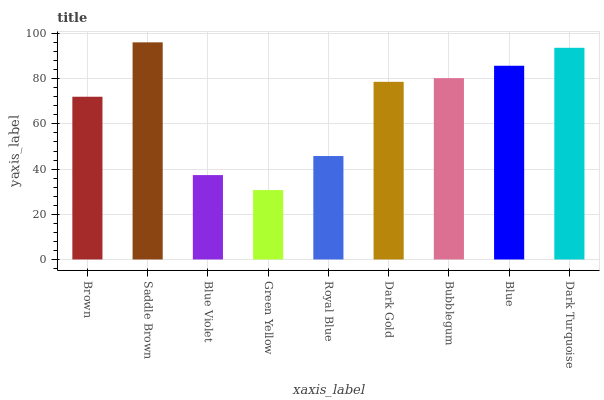Is Green Yellow the minimum?
Answer yes or no. Yes. Is Saddle Brown the maximum?
Answer yes or no. Yes. Is Blue Violet the minimum?
Answer yes or no. No. Is Blue Violet the maximum?
Answer yes or no. No. Is Saddle Brown greater than Blue Violet?
Answer yes or no. Yes. Is Blue Violet less than Saddle Brown?
Answer yes or no. Yes. Is Blue Violet greater than Saddle Brown?
Answer yes or no. No. Is Saddle Brown less than Blue Violet?
Answer yes or no. No. Is Dark Gold the high median?
Answer yes or no. Yes. Is Dark Gold the low median?
Answer yes or no. Yes. Is Blue Violet the high median?
Answer yes or no. No. Is Saddle Brown the low median?
Answer yes or no. No. 